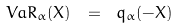Convert formula to latex. <formula><loc_0><loc_0><loc_500><loc_500>V a R _ { \alpha } ( X ) \ = \ q _ { \alpha } ( - X )</formula> 